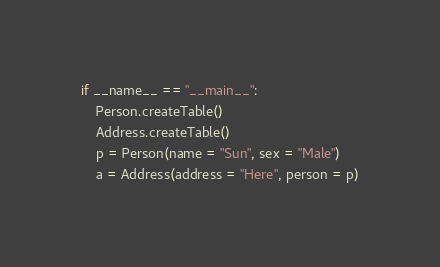<code> <loc_0><loc_0><loc_500><loc_500><_Python_>if __name__ == "__main__":
    Person.createTable()
    Address.createTable()
    p = Person(name = "Sun", sex = "Male")
    a = Address(address = "Here", person = p)
</code> 